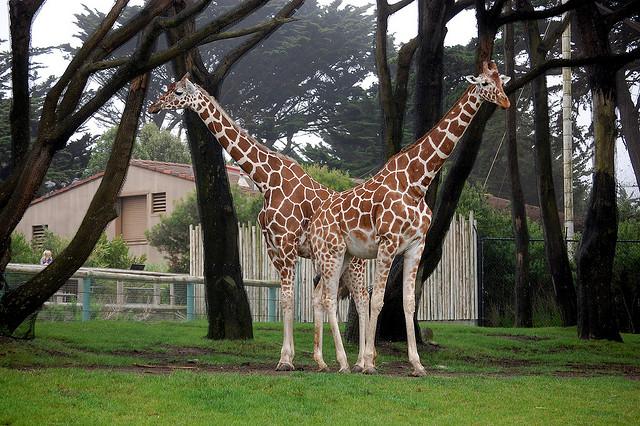What color are the giraffes?
Answer briefly. Brown and white. Are these giraffes young?
Quick response, please. Yes. How many giraffe are standing side by side?
Answer briefly. 2. 